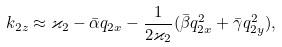<formula> <loc_0><loc_0><loc_500><loc_500>k _ { 2 z } \approx \varkappa _ { 2 } - \bar { \alpha } q _ { 2 x } - \frac { 1 } { 2 \varkappa _ { 2 } } ( \bar { \beta } q _ { 2 x } ^ { 2 } + \bar { \gamma } q _ { 2 y } ^ { 2 } ) ,</formula> 